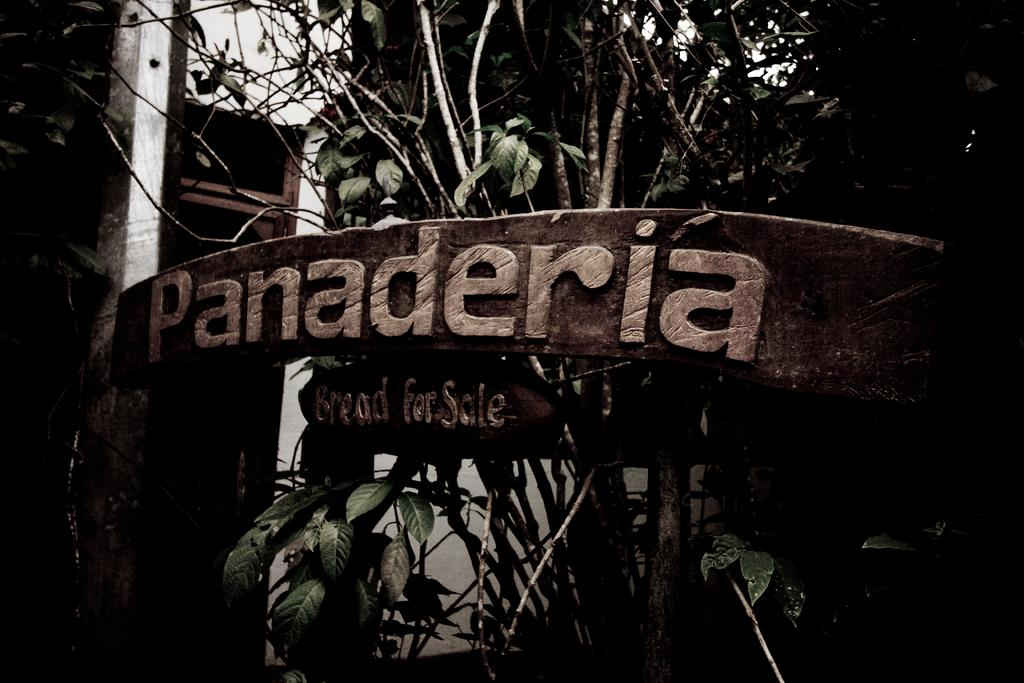What is the main object in the picture? There is a board in the picture. What is featured on the board? There is a carving on the board. What can be seen in the background of the picture? There are trees in the background of the picture. What is the color scheme of the picture? The picture is black and white. Can you tell me how many berries are on the board in the image? There are no berries present in the image; it features a board with a carving. What type of quiver is visible on the board in the image? There is no quiver present on the board in the image; it has a carving instead. 